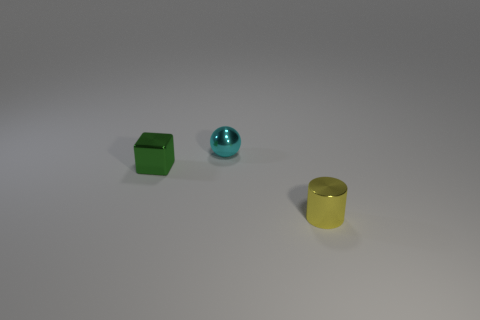What number of things are either things to the left of the tiny yellow thing or tiny things?
Keep it short and to the point. 3. Are there any red things of the same size as the yellow cylinder?
Provide a succinct answer. No. There is a tiny object that is to the right of the shiny sphere; are there any tiny metal objects that are behind it?
Offer a terse response. Yes. How many cylinders are either tiny cyan things or green things?
Provide a short and direct response. 0. The tiny cyan metal thing is what shape?
Give a very brief answer. Sphere. How many objects are big red rubber balls or green metallic blocks?
Give a very brief answer. 1. Does the object in front of the block have the same size as the thing that is on the left side of the tiny cyan object?
Your answer should be very brief. Yes. What number of other things are made of the same material as the sphere?
Ensure brevity in your answer.  2. Are there more tiny cyan metal objects that are behind the small yellow metal cylinder than shiny spheres on the left side of the small shiny block?
Provide a succinct answer. Yes. Are there any other things that have the same color as the tiny shiny cylinder?
Your answer should be very brief. No. 